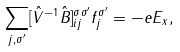<formula> <loc_0><loc_0><loc_500><loc_500>\sum _ { j , \sigma ^ { \prime } } [ \hat { V } ^ { - 1 } \hat { B } ] _ { i j } ^ { \sigma \sigma ^ { \prime } } f _ { j } ^ { \sigma ^ { \prime } } = - e E _ { x } ,</formula> 